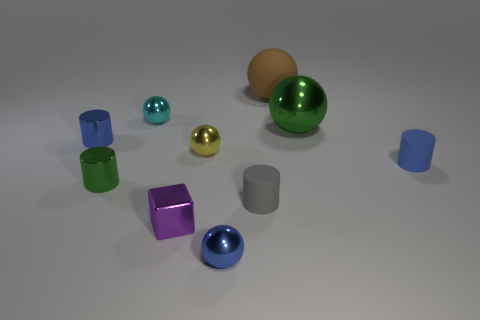How does the lighting in this scene affect the appearance of the objects? The lighting casts subtle shadows and gives a soft highlight to the objects, resulting in a three-dimensional feel that emphasizes the shapes and the metallic or glossy surfaces. The way light interacts with each object brings out their individual textures and colors, accentuating details like the smoothness of the spheres and the sleekness of the cylinders. 